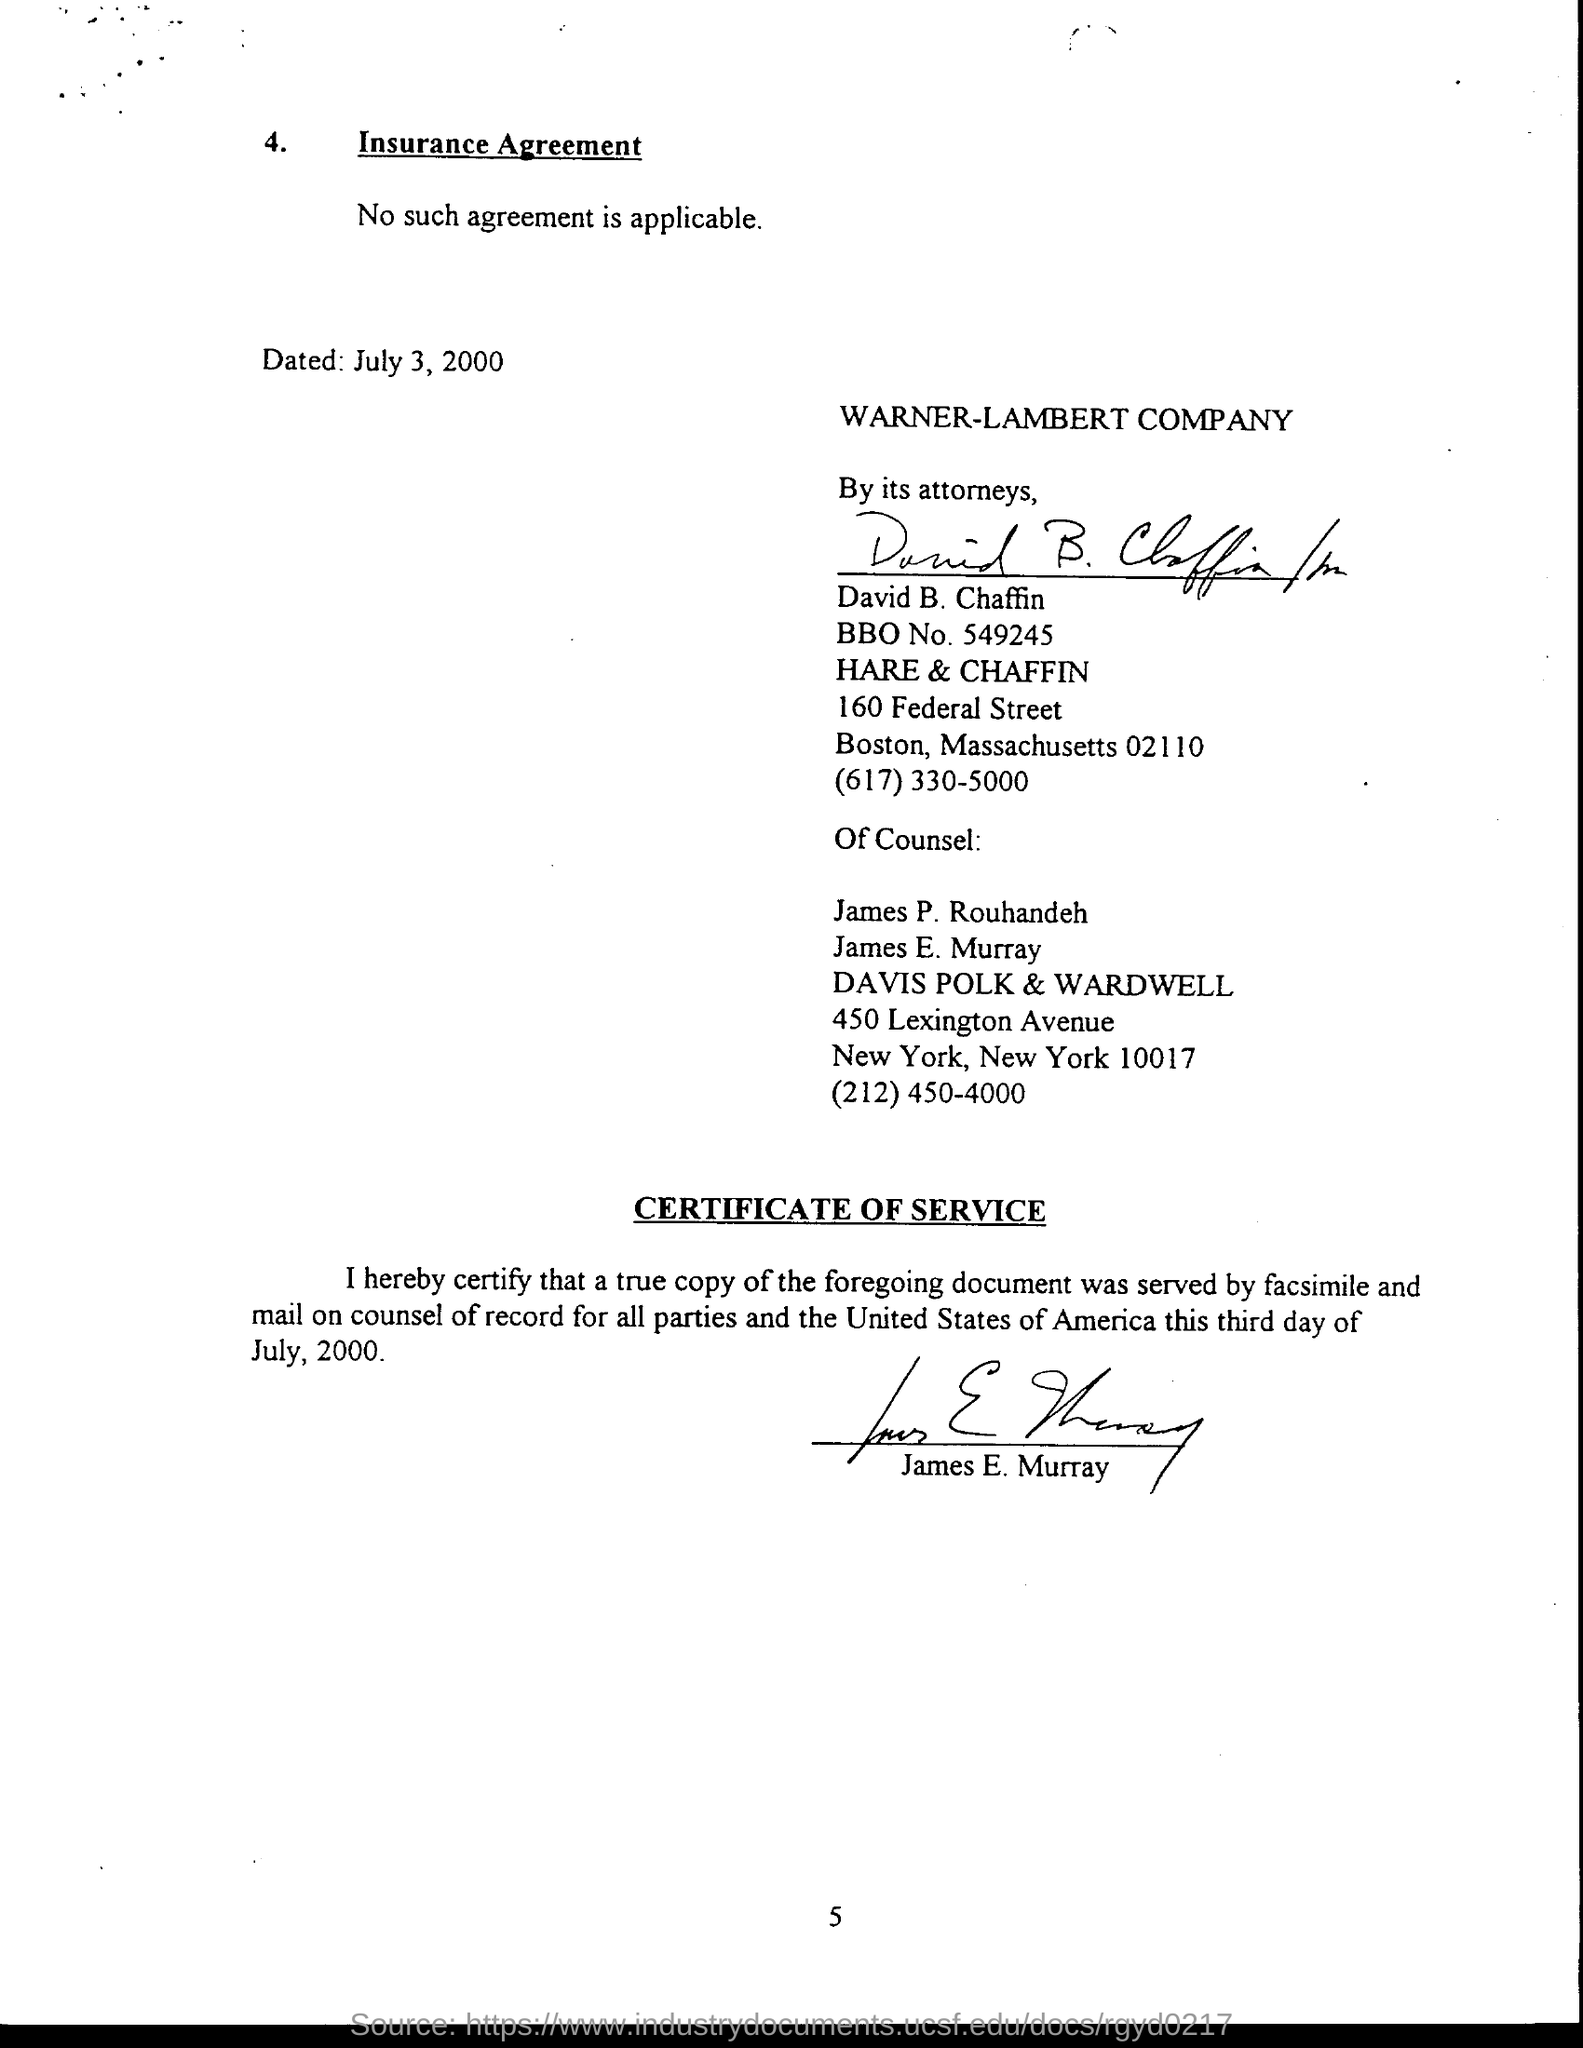When was the agreement dated?
Your answer should be very brief. July 3, 2000. Which company is mentioned?
Offer a terse response. WARNER-LAMBERT COMPANY. 